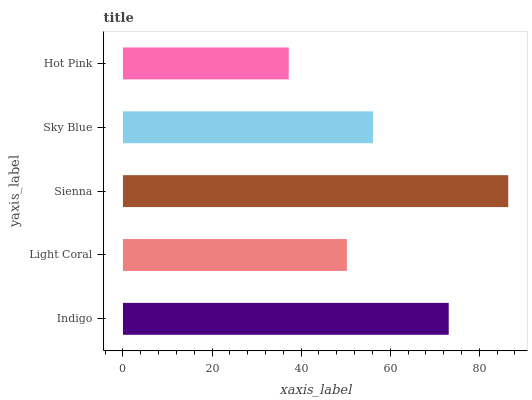Is Hot Pink the minimum?
Answer yes or no. Yes. Is Sienna the maximum?
Answer yes or no. Yes. Is Light Coral the minimum?
Answer yes or no. No. Is Light Coral the maximum?
Answer yes or no. No. Is Indigo greater than Light Coral?
Answer yes or no. Yes. Is Light Coral less than Indigo?
Answer yes or no. Yes. Is Light Coral greater than Indigo?
Answer yes or no. No. Is Indigo less than Light Coral?
Answer yes or no. No. Is Sky Blue the high median?
Answer yes or no. Yes. Is Sky Blue the low median?
Answer yes or no. Yes. Is Light Coral the high median?
Answer yes or no. No. Is Sienna the low median?
Answer yes or no. No. 